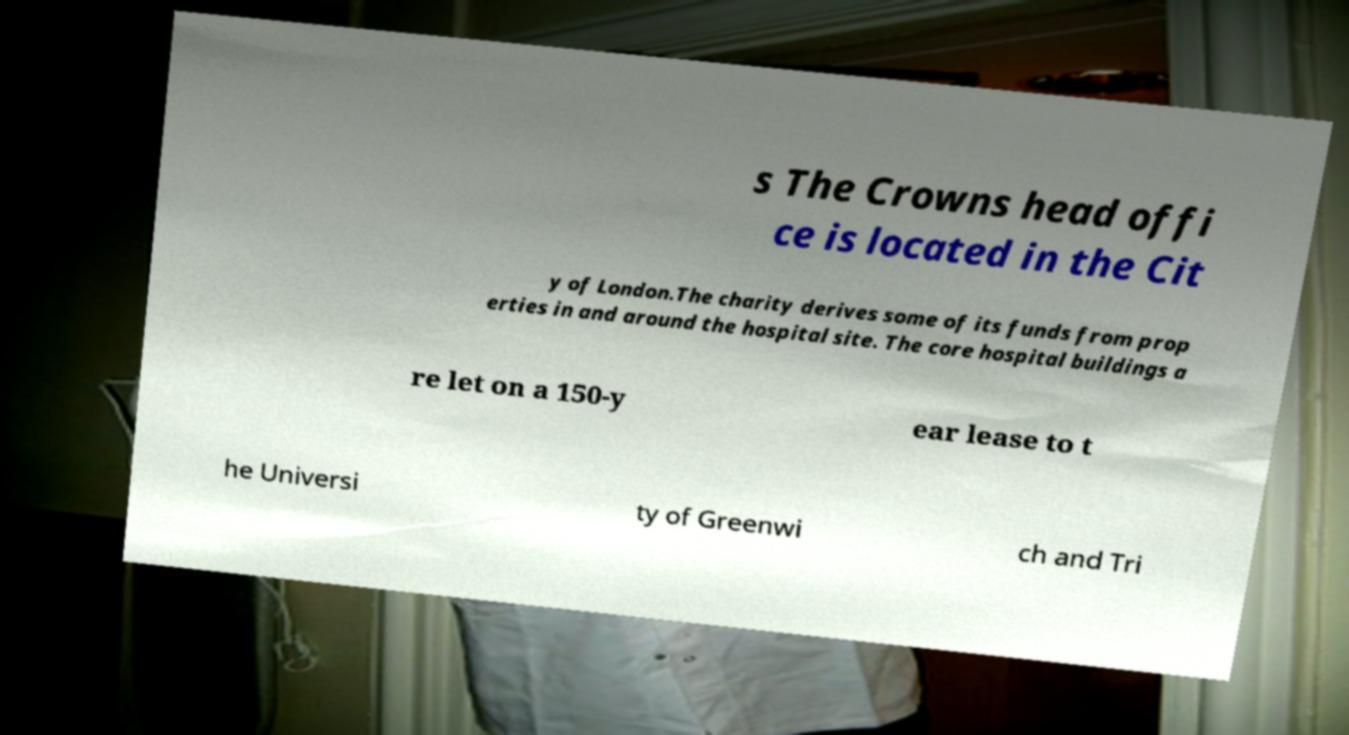Can you accurately transcribe the text from the provided image for me? s The Crowns head offi ce is located in the Cit y of London.The charity derives some of its funds from prop erties in and around the hospital site. The core hospital buildings a re let on a 150-y ear lease to t he Universi ty of Greenwi ch and Tri 